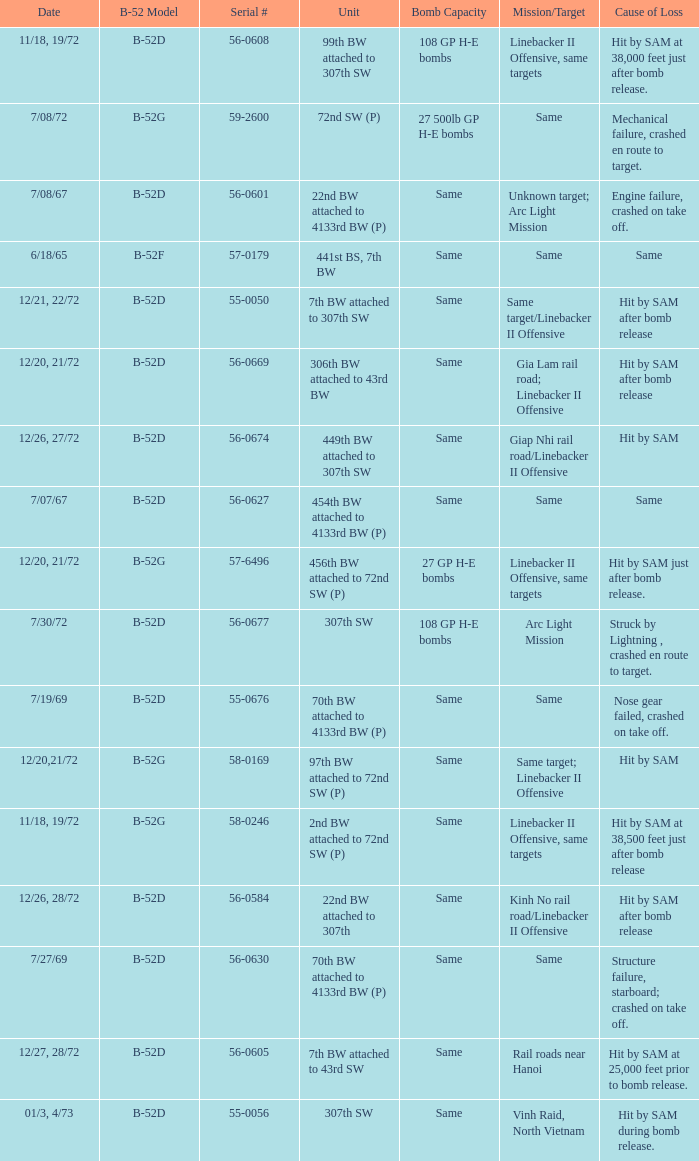When  same target; linebacker ii offensive is the same target what is the unit? 97th BW attached to 72nd SW (P). 